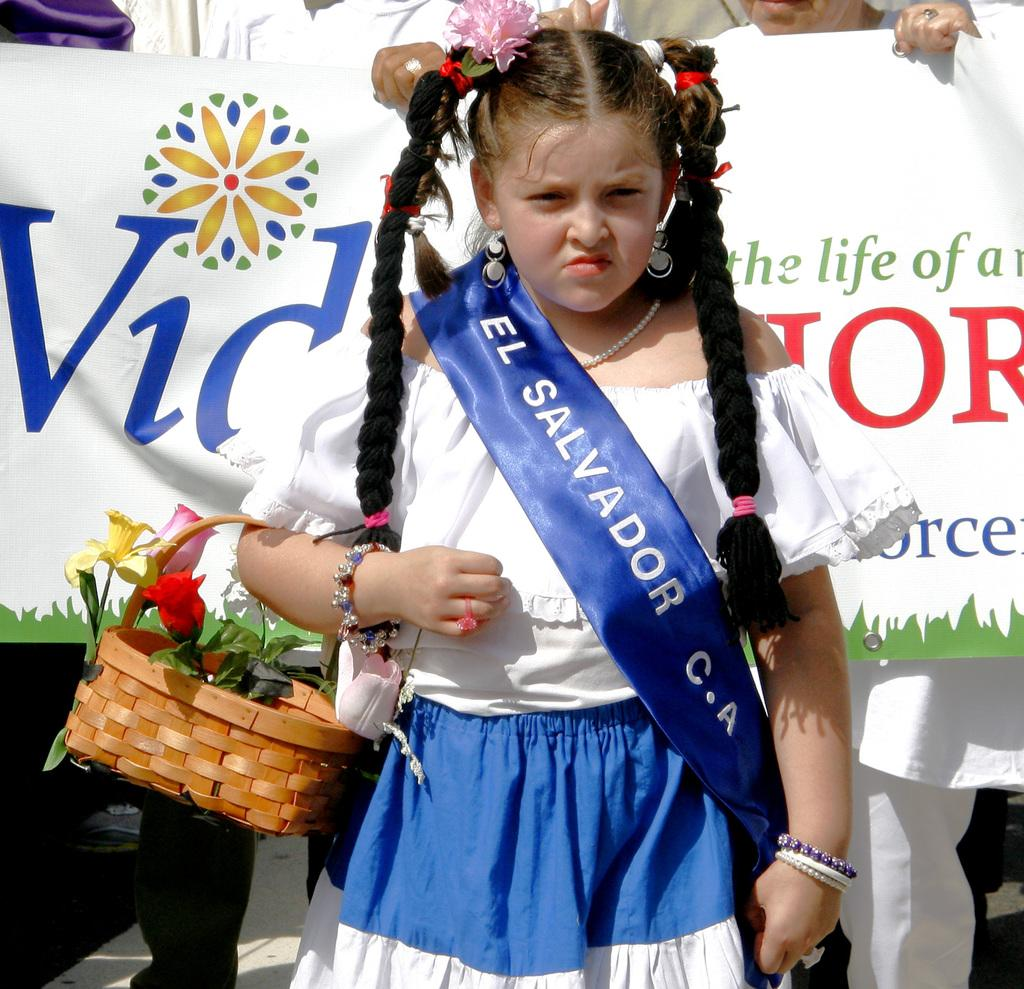<image>
Write a terse but informative summary of the picture. A girl wearing a blue sash that says El Salvador C-A. 